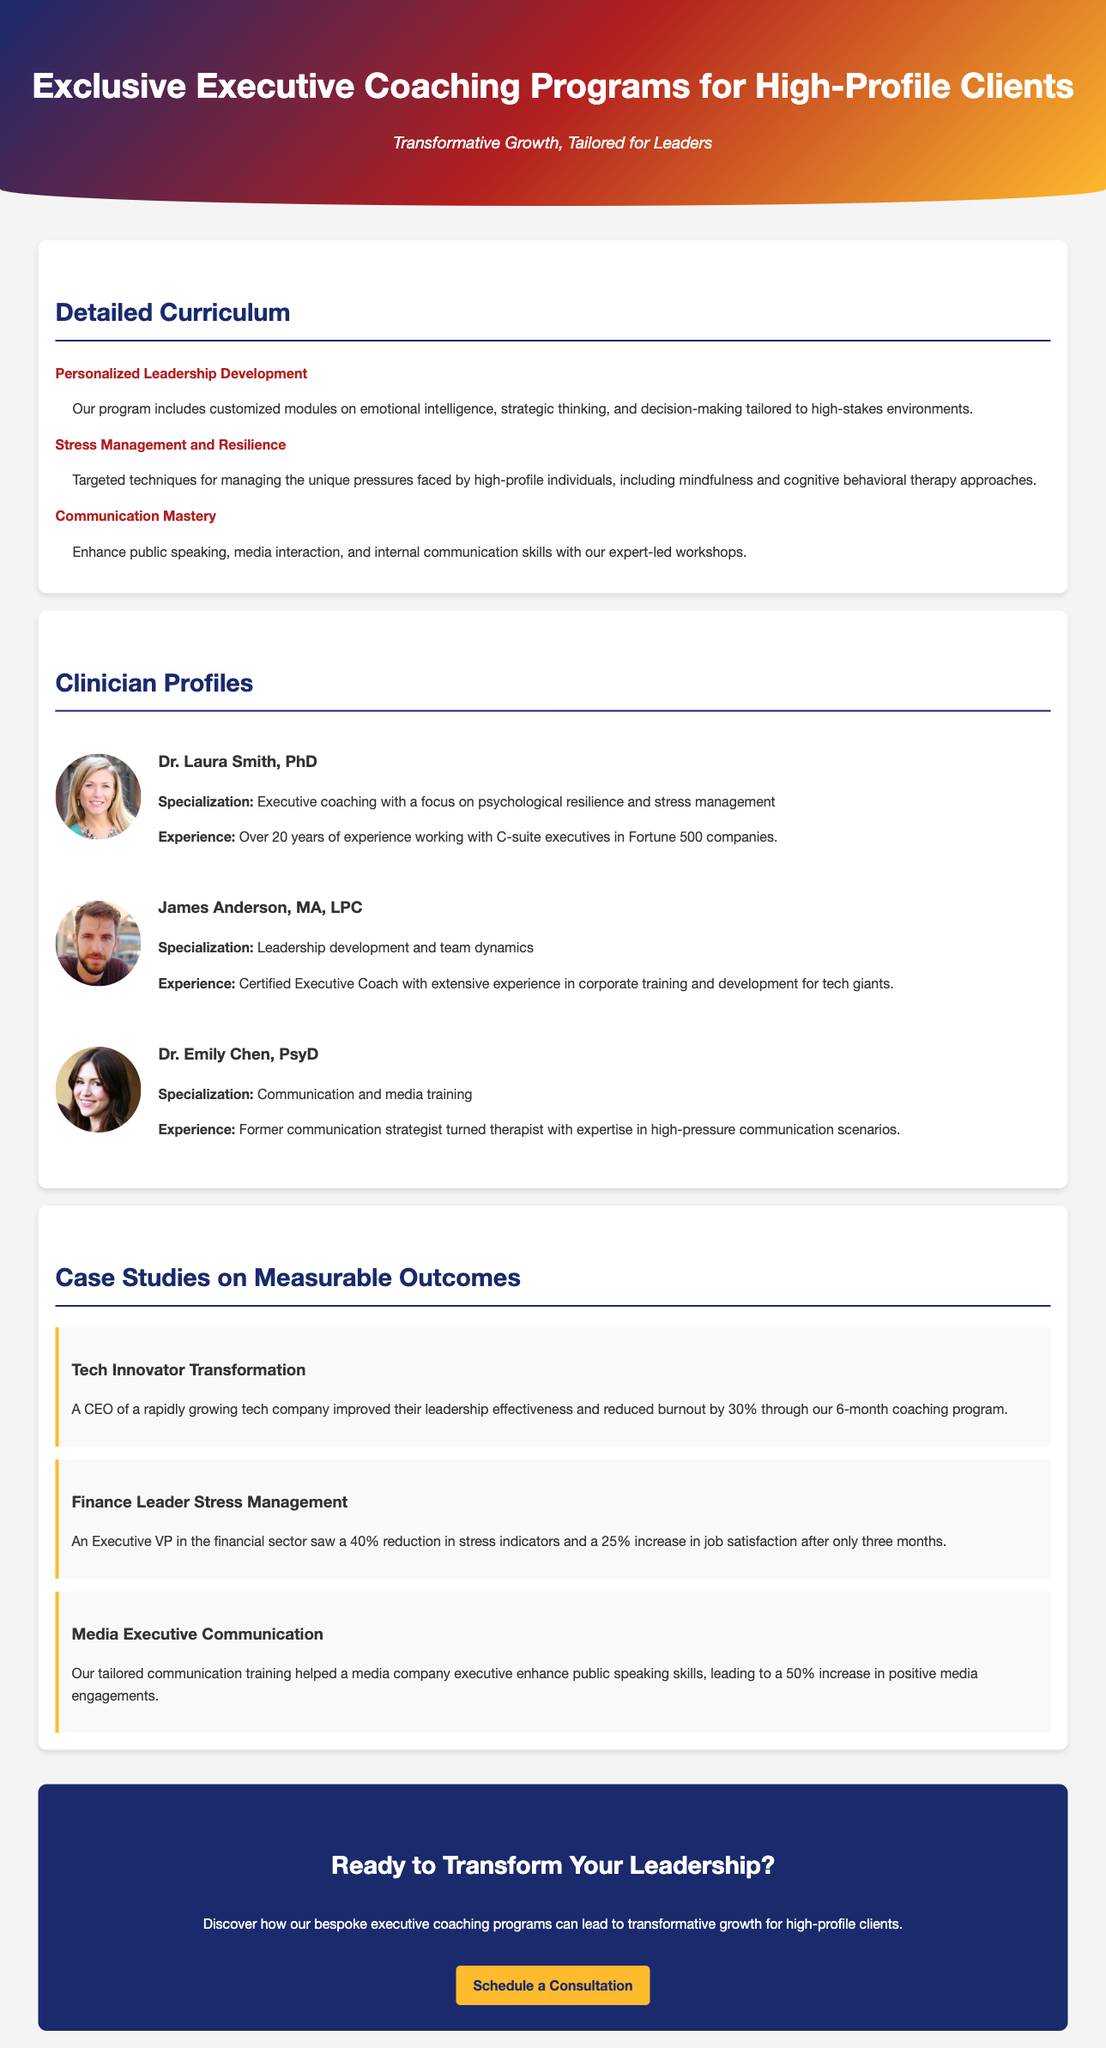What is the focus of the coaching program? The advertisement states that the coaching program focuses on 'Transformative Growth, Tailored for Leaders.'
Answer: Transformative Growth, Tailored for Leaders How many years of experience does Dr. Laura Smith have? The document mentions that Dr. Laura Smith has over 20 years of experience working with C-suite executives.
Answer: Over 20 years What is the specialization of James Anderson? The advertisement lists James Anderson's specialization as 'Leadership development and team dynamics.'
Answer: Leadership development and team dynamics What measurable outcome did the Tech Innovator achieve? The document states that the CEO improved their leadership effectiveness and reduced burnout by 30%.
Answer: 30% Which clinician specializes in communication training? The advertisement specifies that Dr. Emily Chen specializes in communication and media training.
Answer: Dr. Emily Chen How much did the finance leader’s stress indicators decrease? According to the case study, the Executive VP saw a 40% reduction in stress indicators.
Answer: 40% What type of techniques does the program include for stress management? The document lists 'mindfulness and cognitive behavioral therapy approaches' as included techniques for managing stress.
Answer: Mindfulness and cognitive behavioral therapy approaches What call to action is presented in the advertisement? The document has a clear call to action asking readers if they are ready to transform their leadership.
Answer: Ready to Transform Your Leadership? 